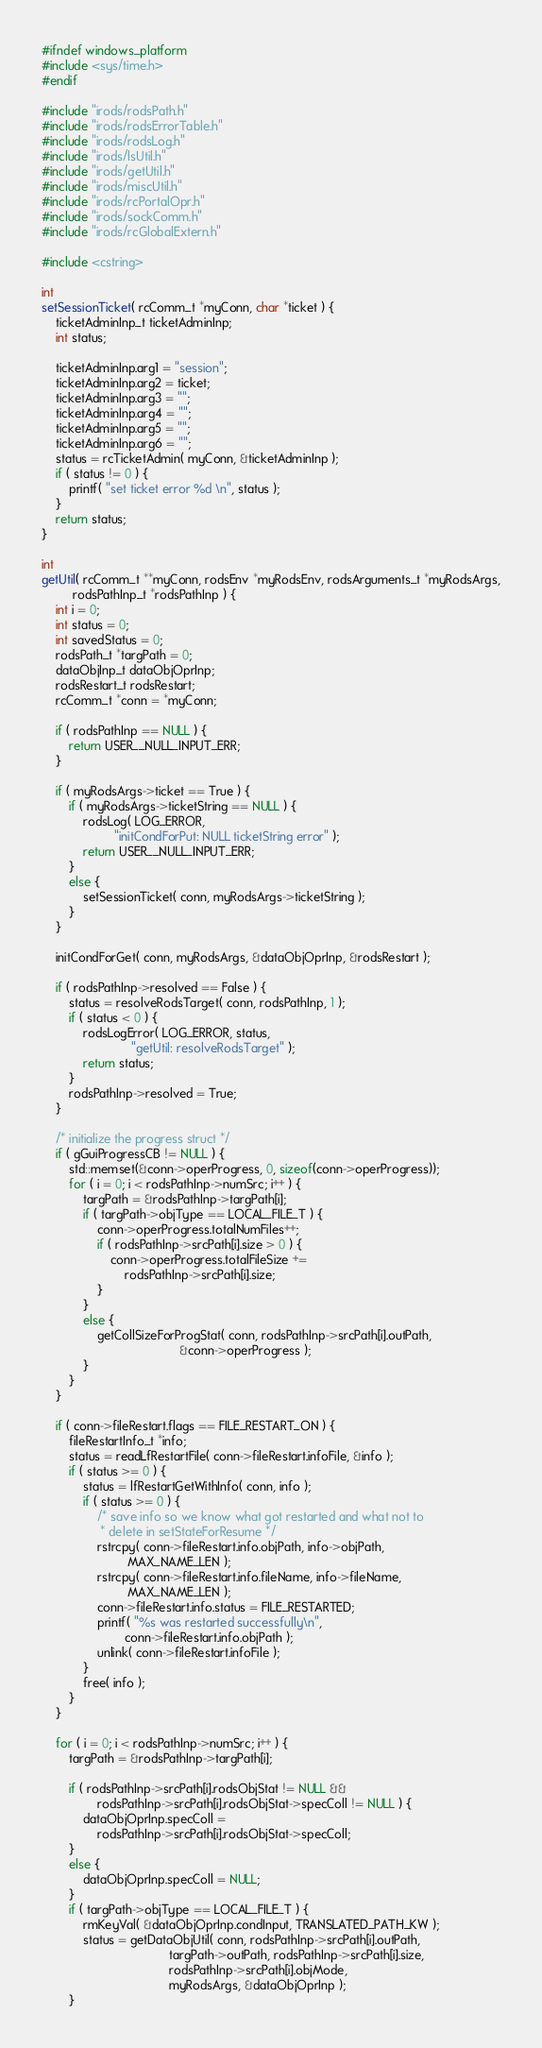<code> <loc_0><loc_0><loc_500><loc_500><_C++_>#ifndef windows_platform
#include <sys/time.h>
#endif

#include "irods/rodsPath.h"
#include "irods/rodsErrorTable.h"
#include "irods/rodsLog.h"
#include "irods/lsUtil.h"
#include "irods/getUtil.h"
#include "irods/miscUtil.h"
#include "irods/rcPortalOpr.h"
#include "irods/sockComm.h"
#include "irods/rcGlobalExtern.h"

#include <cstring>

int
setSessionTicket( rcComm_t *myConn, char *ticket ) {
    ticketAdminInp_t ticketAdminInp;
    int status;

    ticketAdminInp.arg1 = "session";
    ticketAdminInp.arg2 = ticket;
    ticketAdminInp.arg3 = "";
    ticketAdminInp.arg4 = "";
    ticketAdminInp.arg5 = "";
    ticketAdminInp.arg6 = "";
    status = rcTicketAdmin( myConn, &ticketAdminInp );
    if ( status != 0 ) {
        printf( "set ticket error %d \n", status );
    }
    return status;
}

int
getUtil( rcComm_t **myConn, rodsEnv *myRodsEnv, rodsArguments_t *myRodsArgs,
         rodsPathInp_t *rodsPathInp ) {
    int i = 0;
    int status = 0;
    int savedStatus = 0;
    rodsPath_t *targPath = 0;
    dataObjInp_t dataObjOprInp;
    rodsRestart_t rodsRestart;
    rcComm_t *conn = *myConn;

    if ( rodsPathInp == NULL ) {
        return USER__NULL_INPUT_ERR;
    }

    if ( myRodsArgs->ticket == True ) {
        if ( myRodsArgs->ticketString == NULL ) {
            rodsLog( LOG_ERROR,
                     "initCondForPut: NULL ticketString error" );
            return USER__NULL_INPUT_ERR;
        }
        else {
            setSessionTicket( conn, myRodsArgs->ticketString );
        }
    }

    initCondForGet( conn, myRodsArgs, &dataObjOprInp, &rodsRestart );

    if ( rodsPathInp->resolved == False ) {
        status = resolveRodsTarget( conn, rodsPathInp, 1 );
        if ( status < 0 ) {
            rodsLogError( LOG_ERROR, status,
                          "getUtil: resolveRodsTarget" );
            return status;
        }
        rodsPathInp->resolved = True;
    }

    /* initialize the progress struct */
    if ( gGuiProgressCB != NULL ) {
        std::memset(&conn->operProgress, 0, sizeof(conn->operProgress));
        for ( i = 0; i < rodsPathInp->numSrc; i++ ) {
            targPath = &rodsPathInp->targPath[i];
            if ( targPath->objType == LOCAL_FILE_T ) {
                conn->operProgress.totalNumFiles++;
                if ( rodsPathInp->srcPath[i].size > 0 ) {
                    conn->operProgress.totalFileSize +=
                        rodsPathInp->srcPath[i].size;
                }
            }
            else {
                getCollSizeForProgStat( conn, rodsPathInp->srcPath[i].outPath,
                                        &conn->operProgress );
            }
        }
    }

    if ( conn->fileRestart.flags == FILE_RESTART_ON ) {
        fileRestartInfo_t *info;
        status = readLfRestartFile( conn->fileRestart.infoFile, &info );
        if ( status >= 0 ) {
            status = lfRestartGetWithInfo( conn, info );
            if ( status >= 0 ) {
                /* save info so we know what got restarted and what not to
                 * delete in setStateForResume */
                rstrcpy( conn->fileRestart.info.objPath, info->objPath,
                         MAX_NAME_LEN );
                rstrcpy( conn->fileRestart.info.fileName, info->fileName,
                         MAX_NAME_LEN );
                conn->fileRestart.info.status = FILE_RESTARTED;
                printf( "%s was restarted successfully\n",
                        conn->fileRestart.info.objPath );
                unlink( conn->fileRestart.infoFile );
            }
            free( info );
        }
    }

    for ( i = 0; i < rodsPathInp->numSrc; i++ ) {
        targPath = &rodsPathInp->targPath[i];

        if ( rodsPathInp->srcPath[i].rodsObjStat != NULL &&
                rodsPathInp->srcPath[i].rodsObjStat->specColl != NULL ) {
            dataObjOprInp.specColl =
                rodsPathInp->srcPath[i].rodsObjStat->specColl;
        }
        else {
            dataObjOprInp.specColl = NULL;
        }
        if ( targPath->objType == LOCAL_FILE_T ) {
            rmKeyVal( &dataObjOprInp.condInput, TRANSLATED_PATH_KW );
            status = getDataObjUtil( conn, rodsPathInp->srcPath[i].outPath,
                                     targPath->outPath, rodsPathInp->srcPath[i].size,
                                     rodsPathInp->srcPath[i].objMode,
                                     myRodsArgs, &dataObjOprInp );
        }</code> 